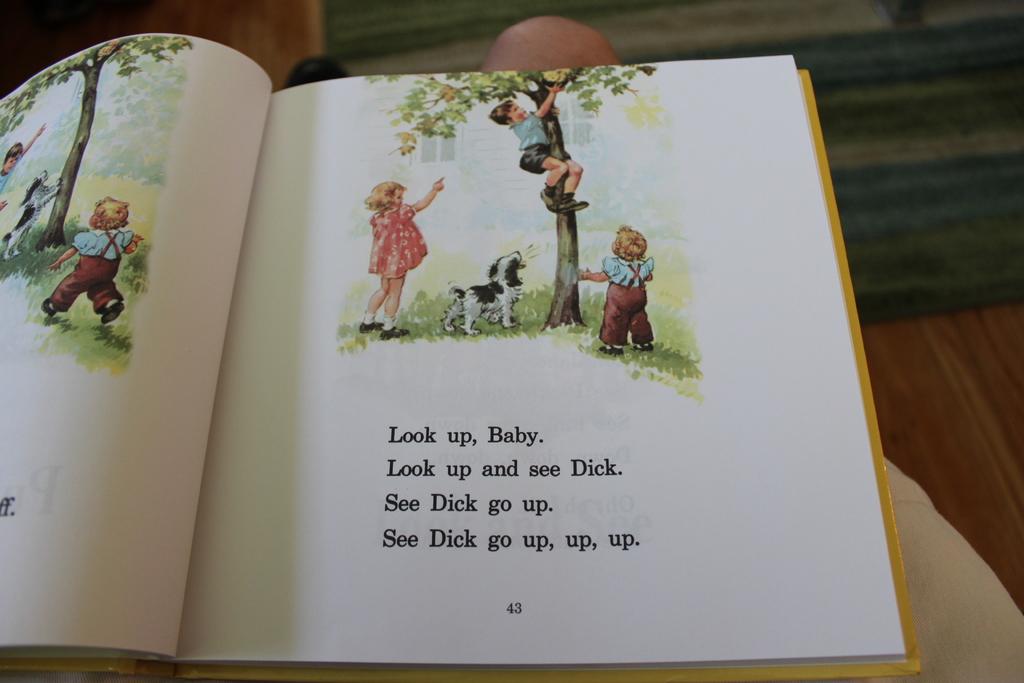What is the name of the boy in the book?
Give a very brief answer. Dick. To what direction is he asked to look?
Your answer should be compact. Up. 